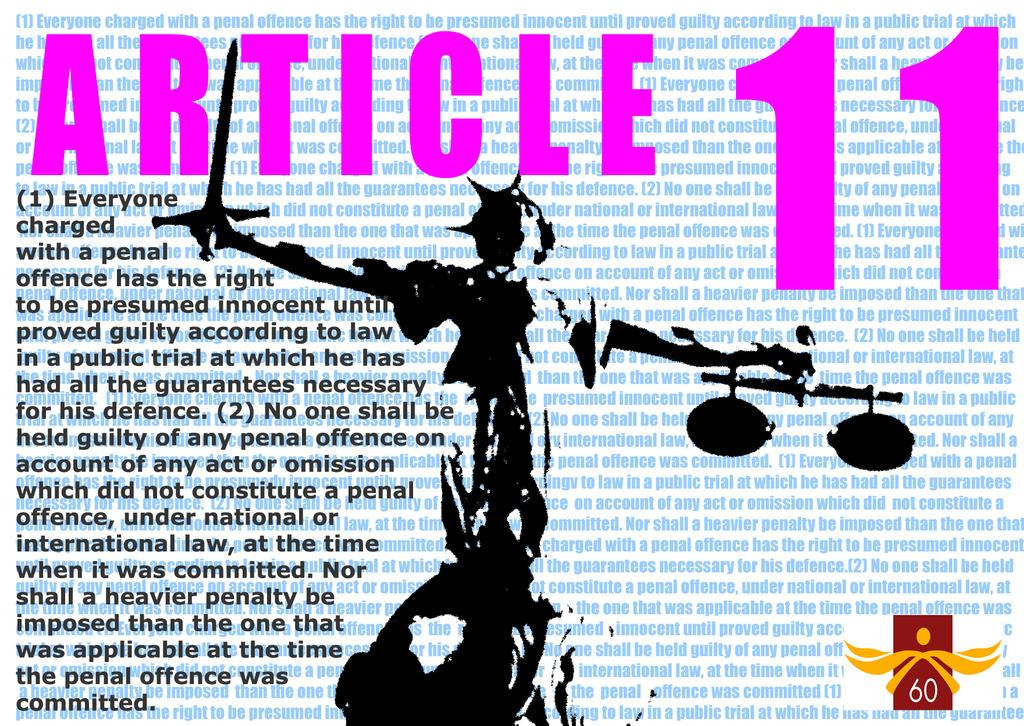<image>
Write a terse but informative summary of the picture. A statue holding a sword for Aricle 11. 